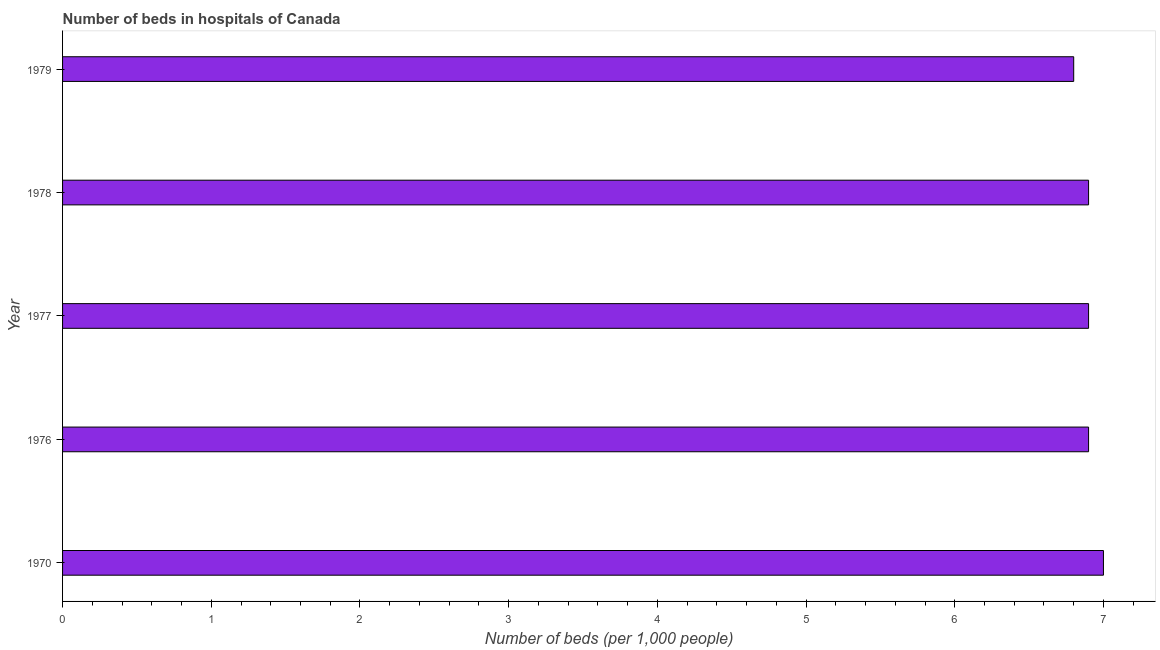What is the title of the graph?
Ensure brevity in your answer.  Number of beds in hospitals of Canada. What is the label or title of the X-axis?
Keep it short and to the point. Number of beds (per 1,0 people). What is the number of hospital beds in 1977?
Your response must be concise. 6.9. Across all years, what is the maximum number of hospital beds?
Provide a succinct answer. 7. Across all years, what is the minimum number of hospital beds?
Offer a very short reply. 6.8. In which year was the number of hospital beds minimum?
Your answer should be compact. 1979. What is the sum of the number of hospital beds?
Your answer should be very brief. 34.5. What is the average number of hospital beds per year?
Give a very brief answer. 6.9. What is the median number of hospital beds?
Keep it short and to the point. 6.9. Do a majority of the years between 1977 and 1979 (inclusive) have number of hospital beds greater than 3.8 %?
Your answer should be compact. Yes. Is the sum of the number of hospital beds in 1970 and 1977 greater than the maximum number of hospital beds across all years?
Your answer should be very brief. Yes. What is the difference between the highest and the lowest number of hospital beds?
Your response must be concise. 0.2. How many bars are there?
Make the answer very short. 5. Are all the bars in the graph horizontal?
Offer a terse response. Yes. How many years are there in the graph?
Ensure brevity in your answer.  5. Are the values on the major ticks of X-axis written in scientific E-notation?
Keep it short and to the point. No. What is the Number of beds (per 1,000 people) of 1976?
Offer a very short reply. 6.9. What is the Number of beds (per 1,000 people) in 1977?
Offer a terse response. 6.9. What is the Number of beds (per 1,000 people) in 1978?
Ensure brevity in your answer.  6.9. What is the Number of beds (per 1,000 people) in 1979?
Your answer should be very brief. 6.8. What is the difference between the Number of beds (per 1,000 people) in 1970 and 1977?
Provide a short and direct response. 0.1. What is the difference between the Number of beds (per 1,000 people) in 1977 and 1978?
Make the answer very short. 0. What is the difference between the Number of beds (per 1,000 people) in 1977 and 1979?
Make the answer very short. 0.1. What is the ratio of the Number of beds (per 1,000 people) in 1970 to that in 1976?
Give a very brief answer. 1.01. What is the ratio of the Number of beds (per 1,000 people) in 1970 to that in 1977?
Make the answer very short. 1.01. What is the ratio of the Number of beds (per 1,000 people) in 1970 to that in 1978?
Provide a short and direct response. 1.01. What is the ratio of the Number of beds (per 1,000 people) in 1977 to that in 1978?
Your answer should be very brief. 1. 